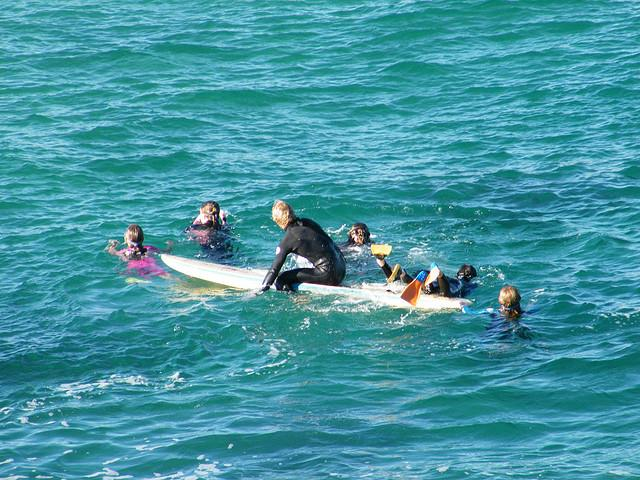What is the orange object on the woman's foot?

Choices:
A) crocs
B) water bottle
C) swimfins
D) socks swimfins 